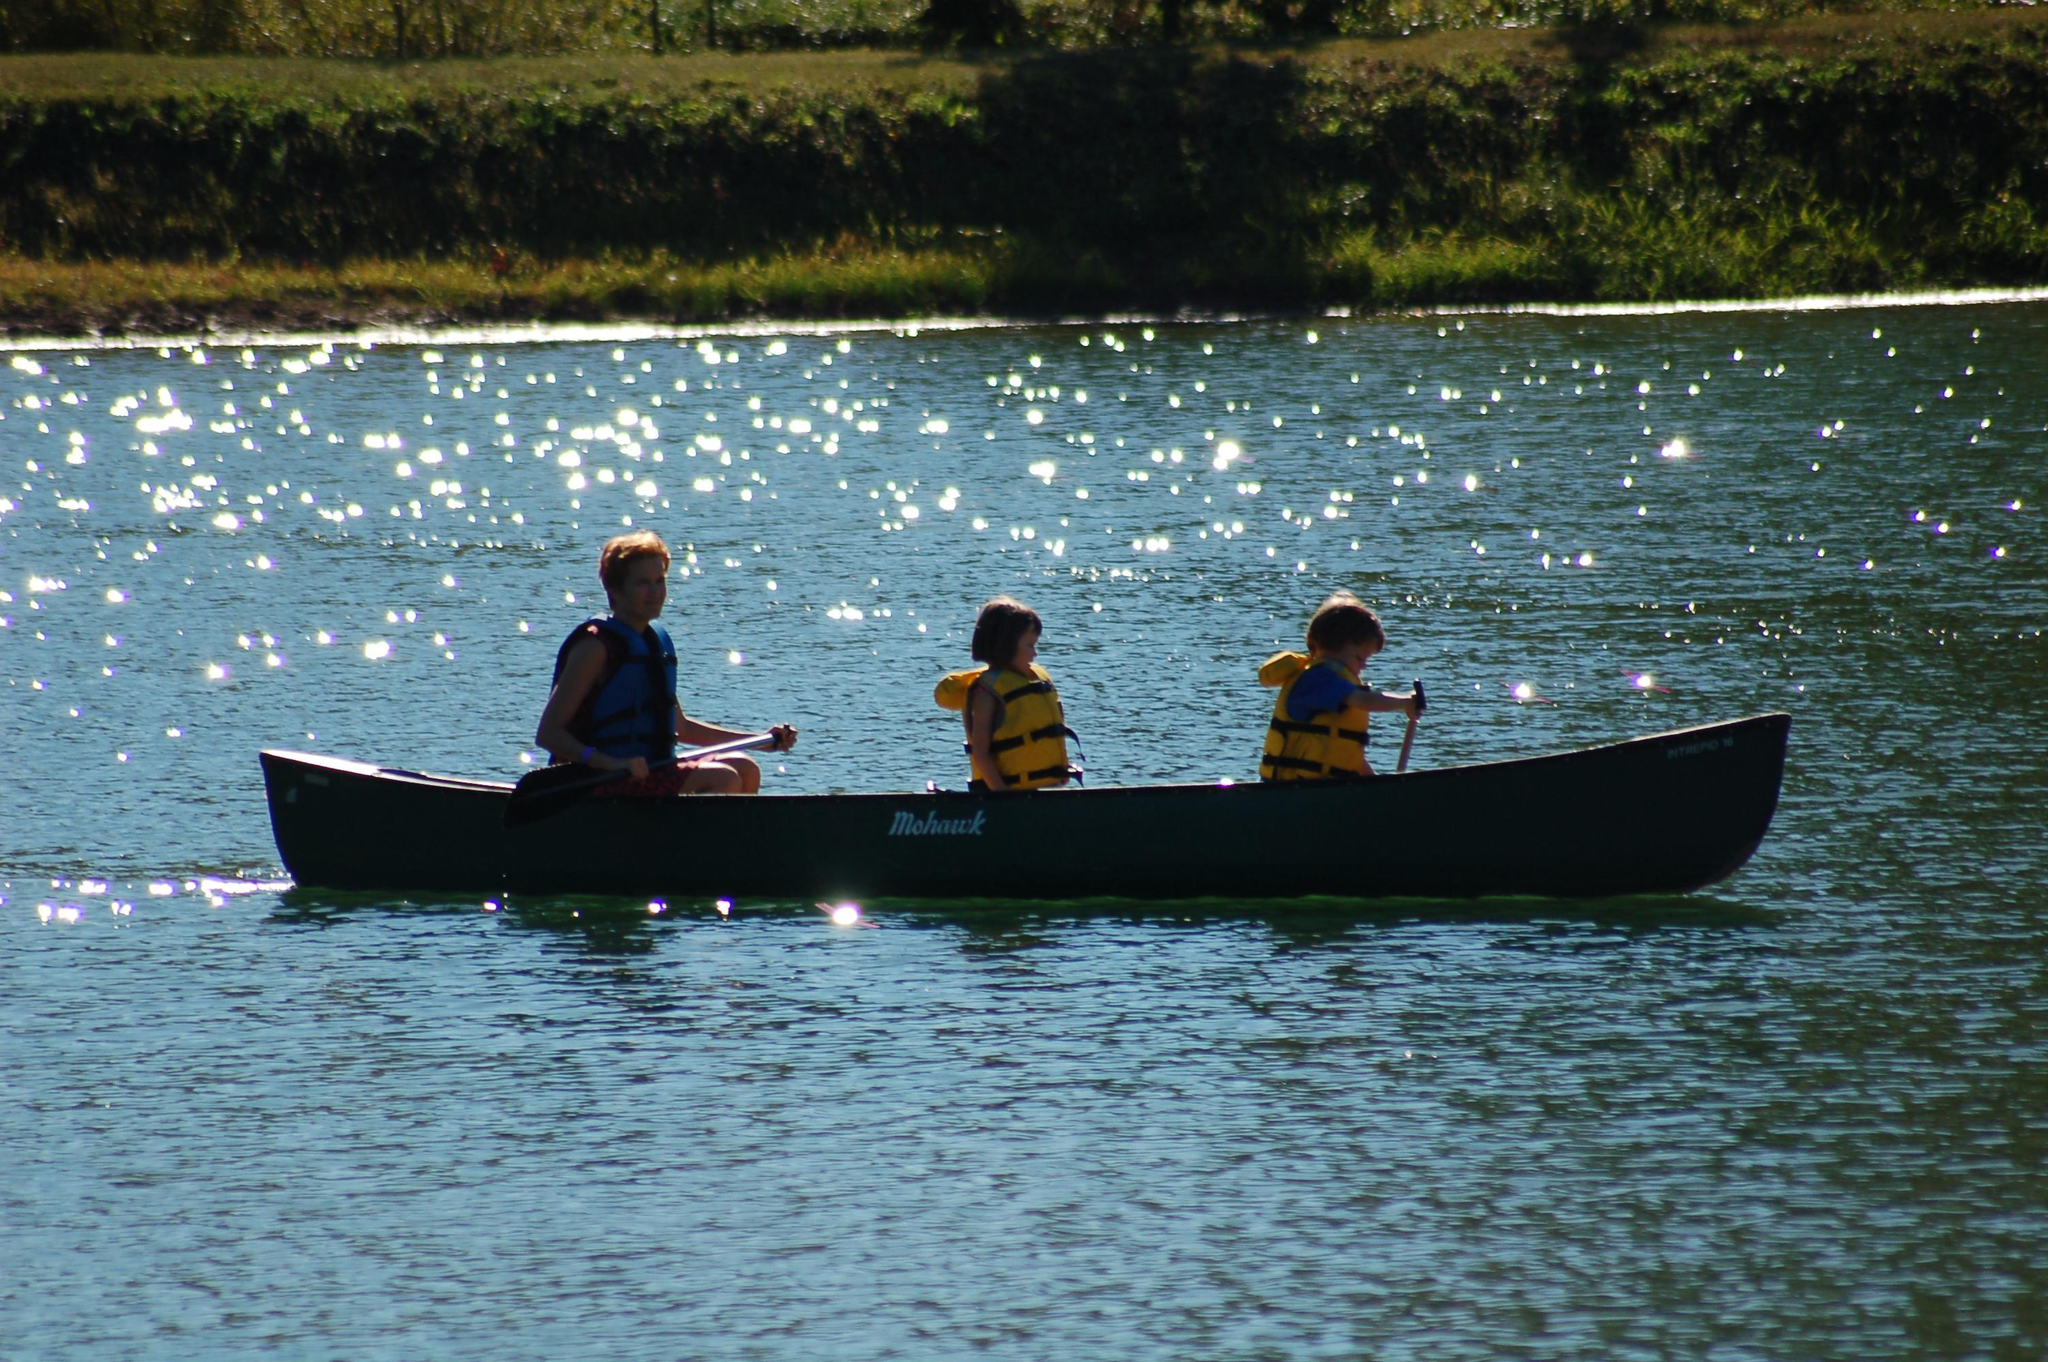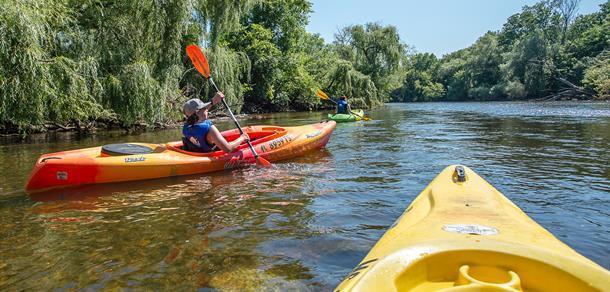The first image is the image on the left, the second image is the image on the right. For the images shown, is this caption "There are three or less people in boats" true? Answer yes or no. Yes. 